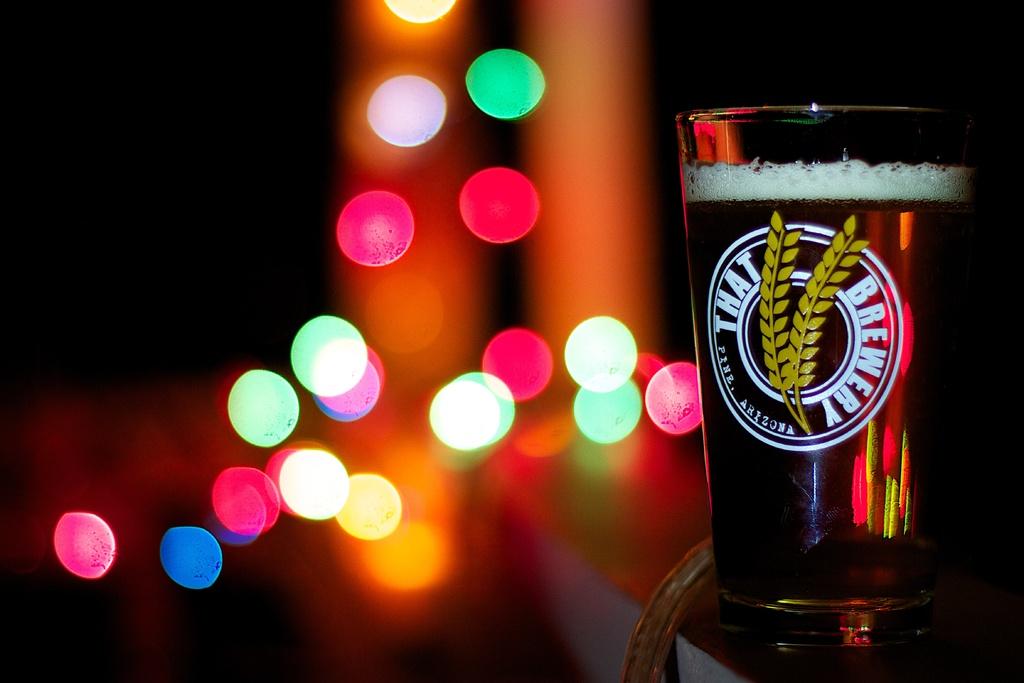Where is this place located?
Provide a short and direct response. Pine, arizona. 